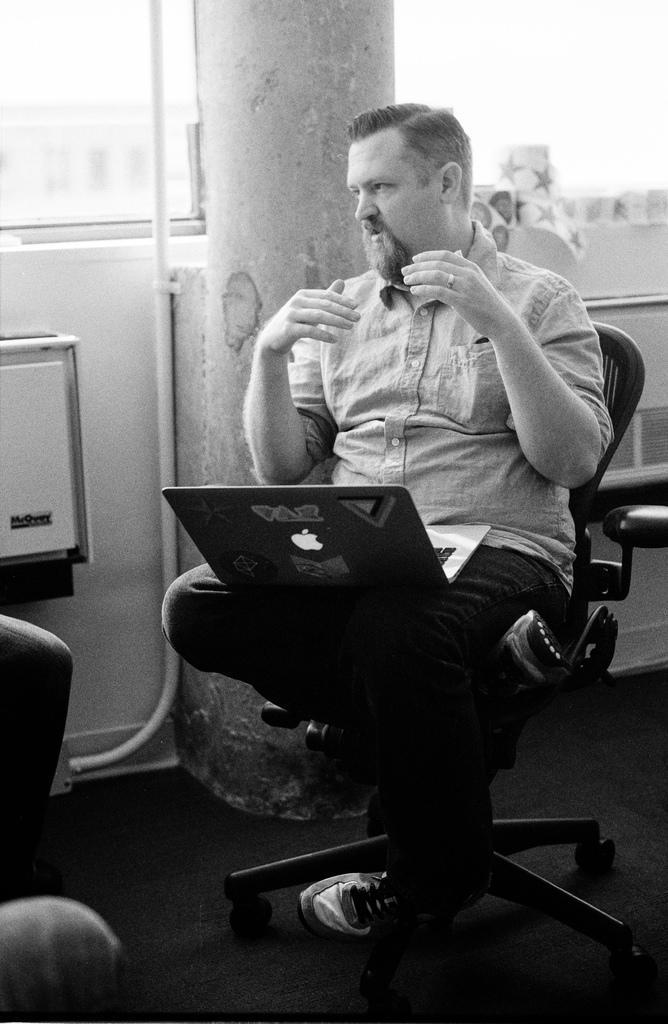Describe this image in one or two sentences. I see this is a black and white image and I see a man over here who is sitting on this chair and I see a laptop on him and I see the logo over here and I see the floor. In the background I see the wall and I see the pipe over here. 